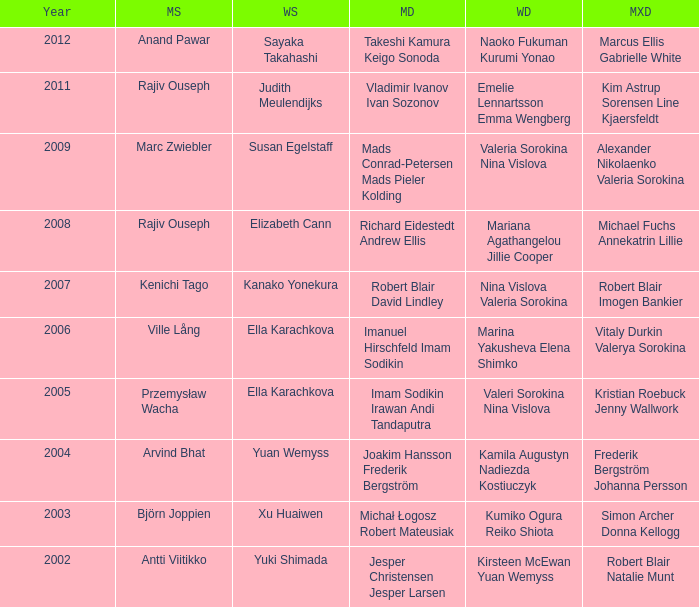Would you be able to parse every entry in this table? {'header': ['Year', 'MS', 'WS', 'MD', 'WD', 'MXD'], 'rows': [['2012', 'Anand Pawar', 'Sayaka Takahashi', 'Takeshi Kamura Keigo Sonoda', 'Naoko Fukuman Kurumi Yonao', 'Marcus Ellis Gabrielle White'], ['2011', 'Rajiv Ouseph', 'Judith Meulendijks', 'Vladimir Ivanov Ivan Sozonov', 'Emelie Lennartsson Emma Wengberg', 'Kim Astrup Sorensen Line Kjaersfeldt'], ['2009', 'Marc Zwiebler', 'Susan Egelstaff', 'Mads Conrad-Petersen Mads Pieler Kolding', 'Valeria Sorokina Nina Vislova', 'Alexander Nikolaenko Valeria Sorokina'], ['2008', 'Rajiv Ouseph', 'Elizabeth Cann', 'Richard Eidestedt Andrew Ellis', 'Mariana Agathangelou Jillie Cooper', 'Michael Fuchs Annekatrin Lillie'], ['2007', 'Kenichi Tago', 'Kanako Yonekura', 'Robert Blair David Lindley', 'Nina Vislova Valeria Sorokina', 'Robert Blair Imogen Bankier'], ['2006', 'Ville Lång', 'Ella Karachkova', 'Imanuel Hirschfeld Imam Sodikin', 'Marina Yakusheva Elena Shimko', 'Vitaly Durkin Valerya Sorokina'], ['2005', 'Przemysław Wacha', 'Ella Karachkova', 'Imam Sodikin Irawan Andi Tandaputra', 'Valeri Sorokina Nina Vislova', 'Kristian Roebuck Jenny Wallwork'], ['2004', 'Arvind Bhat', 'Yuan Wemyss', 'Joakim Hansson Frederik Bergström', 'Kamila Augustyn Nadiezda Kostiuczyk', 'Frederik Bergström Johanna Persson'], ['2003', 'Björn Joppien', 'Xu Huaiwen', 'Michał Łogosz Robert Mateusiak', 'Kumiko Ogura Reiko Shiota', 'Simon Archer Donna Kellogg'], ['2002', 'Antti Viitikko', 'Yuki Shimada', 'Jesper Christensen Jesper Larsen', 'Kirsteen McEwan Yuan Wemyss', 'Robert Blair Natalie Munt']]} What are the womens singles of imam sodikin irawan andi tandaputra? Ella Karachkova. 